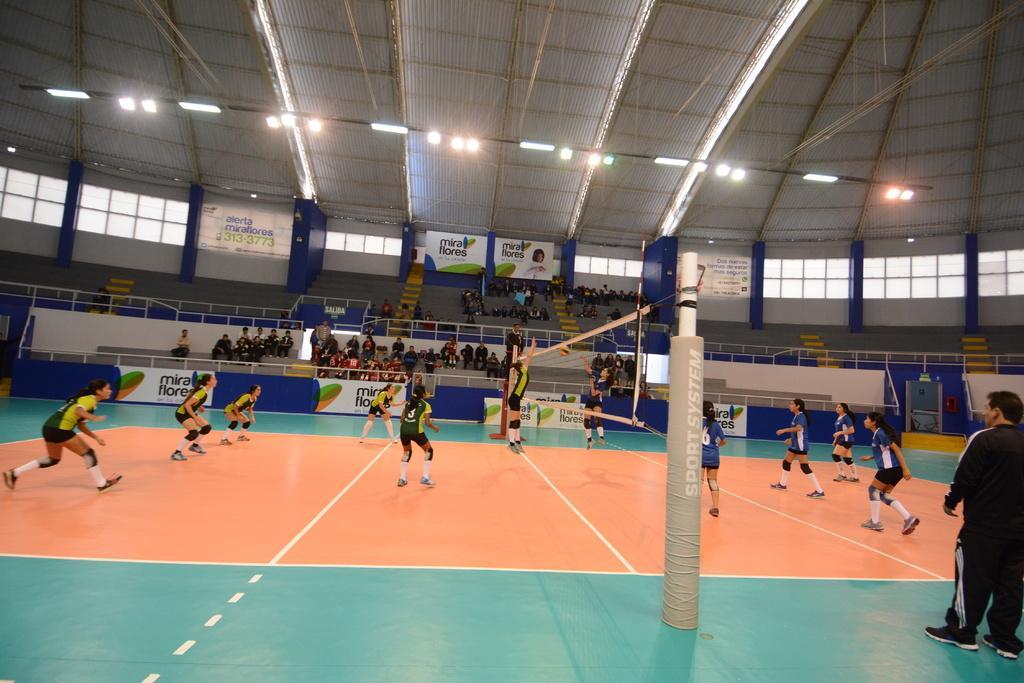Could you give a brief overview of what you see in this image? This is the picture of a stadium. In this image there are group of people standing and two persons are jumping at the pole. At the back there are group of people sitting in the stadium. In the foreground there are two poles and there is a net. At the back there are hoardings. At the top there are lights. 